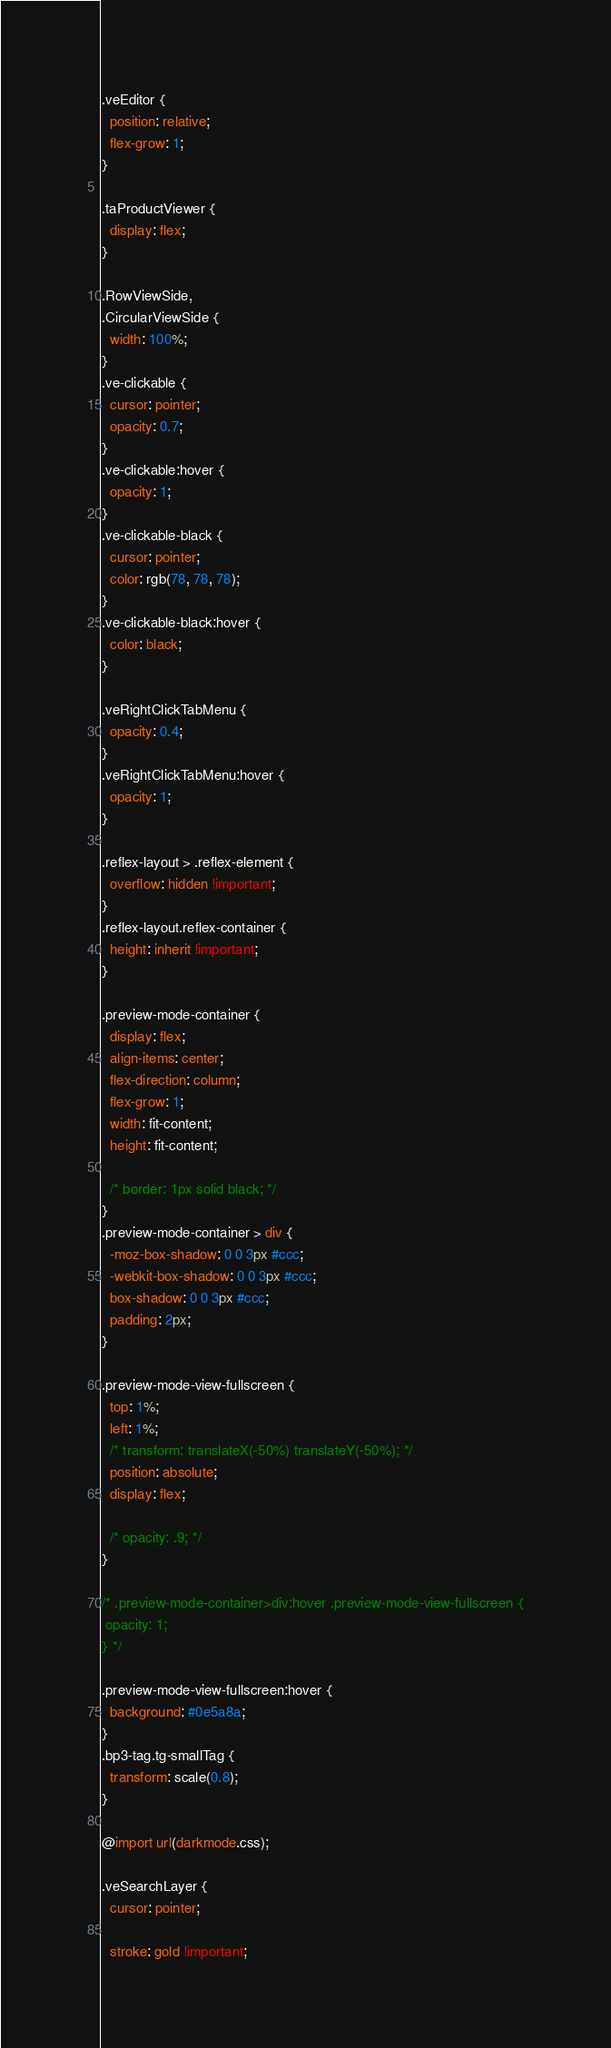Convert code to text. <code><loc_0><loc_0><loc_500><loc_500><_CSS_>.veEditor {
  position: relative;
  flex-grow: 1;
}

.taProductViewer {
  display: flex;
}

.RowViewSide,
.CircularViewSide {
  width: 100%;
}
.ve-clickable {
  cursor: pointer;
  opacity: 0.7;
}
.ve-clickable:hover {
  opacity: 1;
}
.ve-clickable-black {
  cursor: pointer;
  color: rgb(78, 78, 78);
}
.ve-clickable-black:hover {
  color: black;
}

.veRightClickTabMenu {
  opacity: 0.4;
}
.veRightClickTabMenu:hover {
  opacity: 1;
}

.reflex-layout > .reflex-element {
  overflow: hidden !important;
}
.reflex-layout.reflex-container {
  height: inherit !important;
}

.preview-mode-container {
  display: flex;
  align-items: center;
  flex-direction: column;
  flex-grow: 1;
  width: fit-content;
  height: fit-content;

  /* border: 1px solid black; */
}
.preview-mode-container > div {
  -moz-box-shadow: 0 0 3px #ccc;
  -webkit-box-shadow: 0 0 3px #ccc;
  box-shadow: 0 0 3px #ccc;
  padding: 2px;
}

.preview-mode-view-fullscreen {
  top: 1%;
  left: 1%;
  /* transform: translateX(-50%) translateY(-50%); */
  position: absolute;
  display: flex;

  /* opacity: .9; */
}

/* .preview-mode-container>div:hover .preview-mode-view-fullscreen {
 opacity: 1;
} */

.preview-mode-view-fullscreen:hover {
  background: #0e5a8a;
}
.bp3-tag.tg-smallTag {
  transform: scale(0.8);
}

@import url(darkmode.css);

.veSearchLayer {
  cursor: pointer;

  stroke: gold !important;</code> 